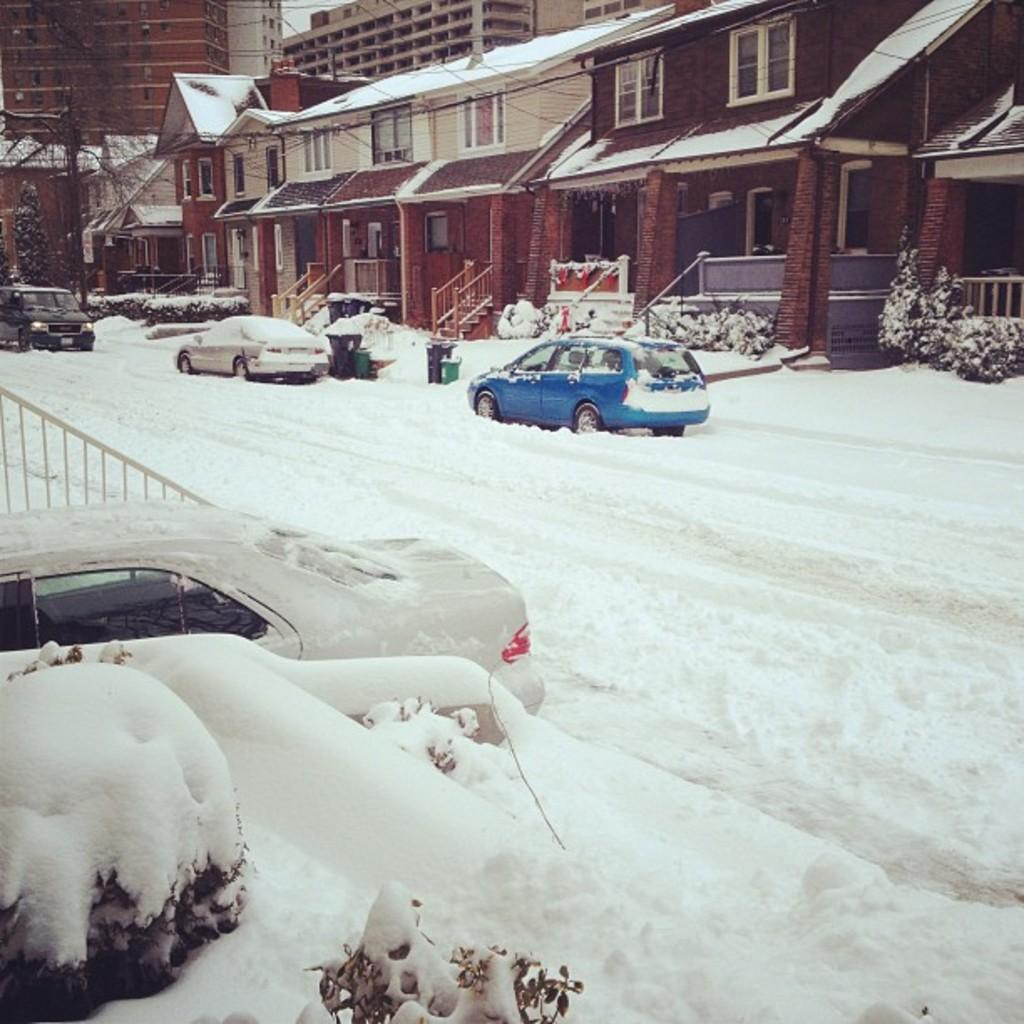What can be seen in the front of the image? In the front of the image, there are vehicles, plants, snow, and railing. What is visible in the background of the image? In the background of the image, there are houses, plants, railing, a tree, bins, and other objects. What type of record can be seen in the image? There is no record present in the image. What industry is depicted in the image? The image does not depict any specific industry. 